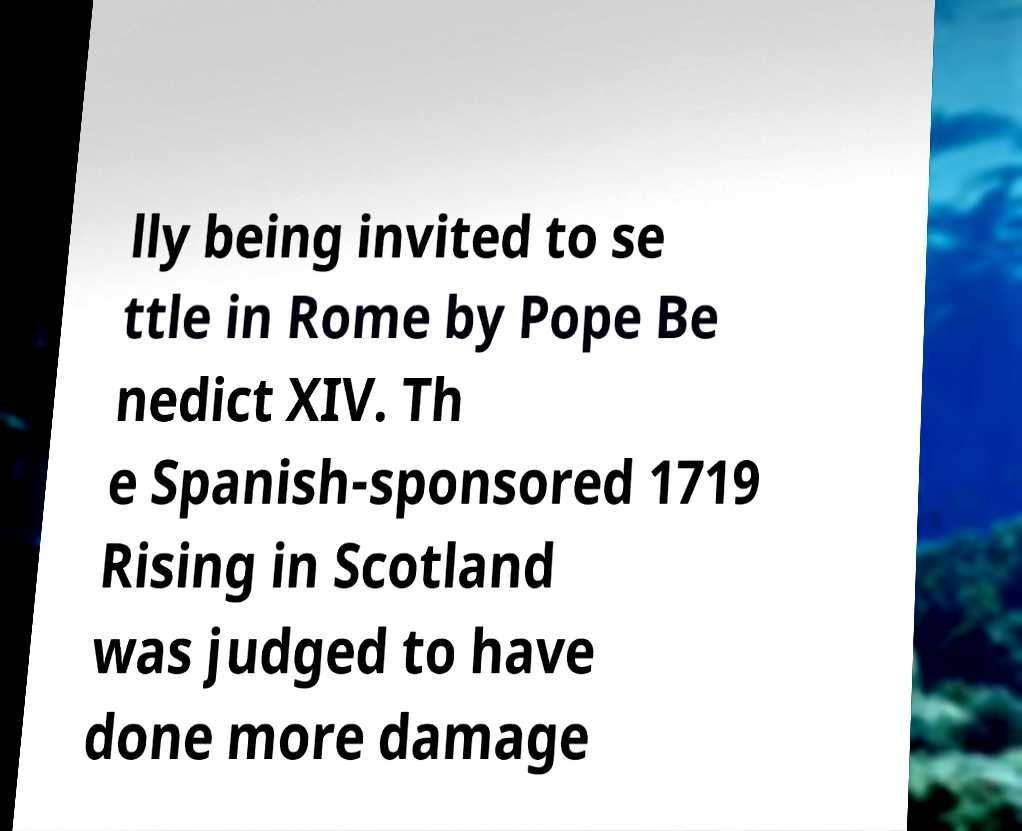I need the written content from this picture converted into text. Can you do that? lly being invited to se ttle in Rome by Pope Be nedict XIV. Th e Spanish-sponsored 1719 Rising in Scotland was judged to have done more damage 